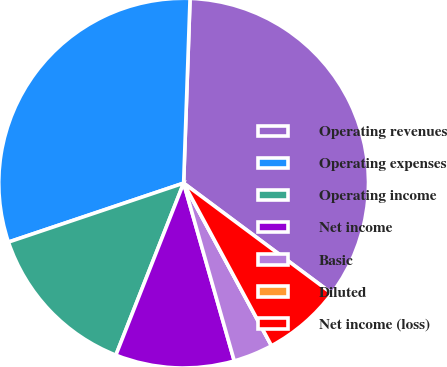<chart> <loc_0><loc_0><loc_500><loc_500><pie_chart><fcel>Operating revenues<fcel>Operating expenses<fcel>Operating income<fcel>Net income<fcel>Basic<fcel>Diluted<fcel>Net income (loss)<nl><fcel>34.63%<fcel>30.72%<fcel>13.86%<fcel>10.39%<fcel>3.47%<fcel>0.0%<fcel>6.93%<nl></chart> 